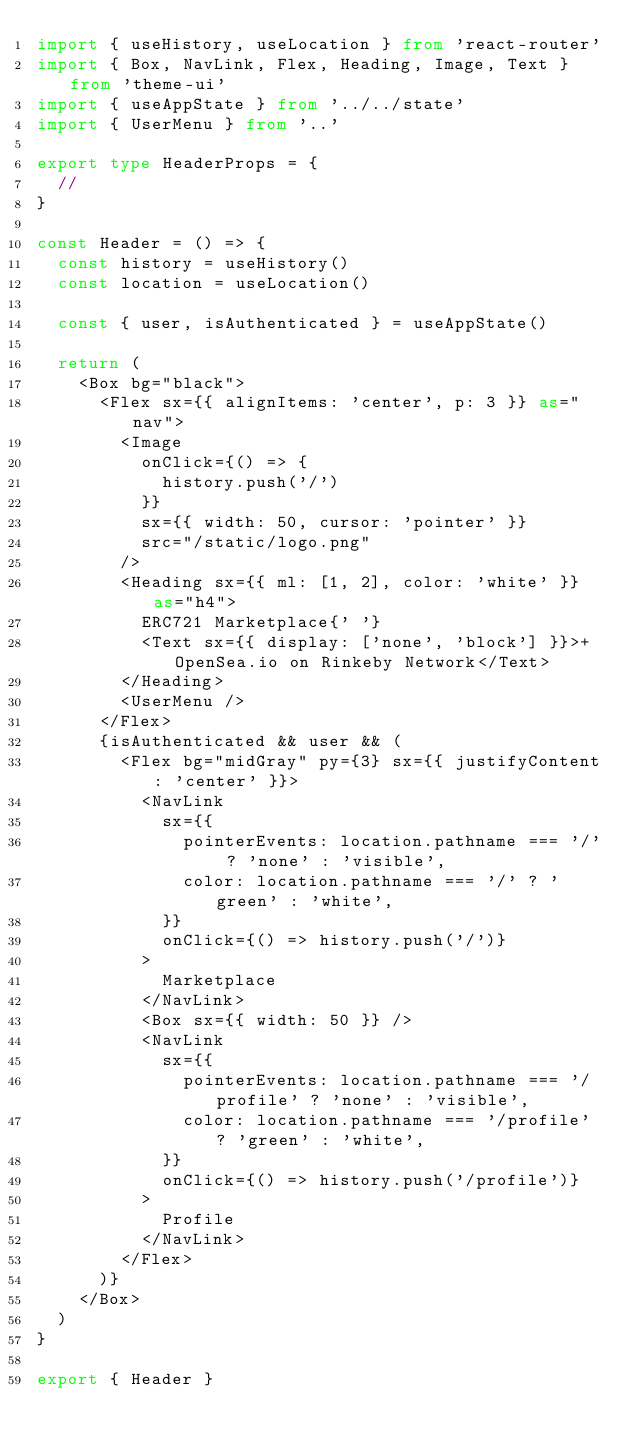<code> <loc_0><loc_0><loc_500><loc_500><_TypeScript_>import { useHistory, useLocation } from 'react-router'
import { Box, NavLink, Flex, Heading, Image, Text } from 'theme-ui'
import { useAppState } from '../../state'
import { UserMenu } from '..'

export type HeaderProps = {
  //
}

const Header = () => {
  const history = useHistory()
  const location = useLocation()

  const { user, isAuthenticated } = useAppState()

  return (
    <Box bg="black">
      <Flex sx={{ alignItems: 'center', p: 3 }} as="nav">
        <Image
          onClick={() => {
            history.push('/')
          }}
          sx={{ width: 50, cursor: 'pointer' }}
          src="/static/logo.png"
        />
        <Heading sx={{ ml: [1, 2], color: 'white' }} as="h4">
          ERC721 Marketplace{' '}
          <Text sx={{ display: ['none', 'block'] }}>+ OpenSea.io on Rinkeby Network</Text>
        </Heading>
        <UserMenu />
      </Flex>
      {isAuthenticated && user && (
        <Flex bg="midGray" py={3} sx={{ justifyContent: 'center' }}>
          <NavLink
            sx={{
              pointerEvents: location.pathname === '/' ? 'none' : 'visible',
              color: location.pathname === '/' ? 'green' : 'white',
            }}
            onClick={() => history.push('/')}
          >
            Marketplace
          </NavLink>
          <Box sx={{ width: 50 }} />
          <NavLink
            sx={{
              pointerEvents: location.pathname === '/profile' ? 'none' : 'visible',
              color: location.pathname === '/profile' ? 'green' : 'white',
            }}
            onClick={() => history.push('/profile')}
          >
            Profile
          </NavLink>
        </Flex>
      )}
    </Box>
  )
}

export { Header }
</code> 